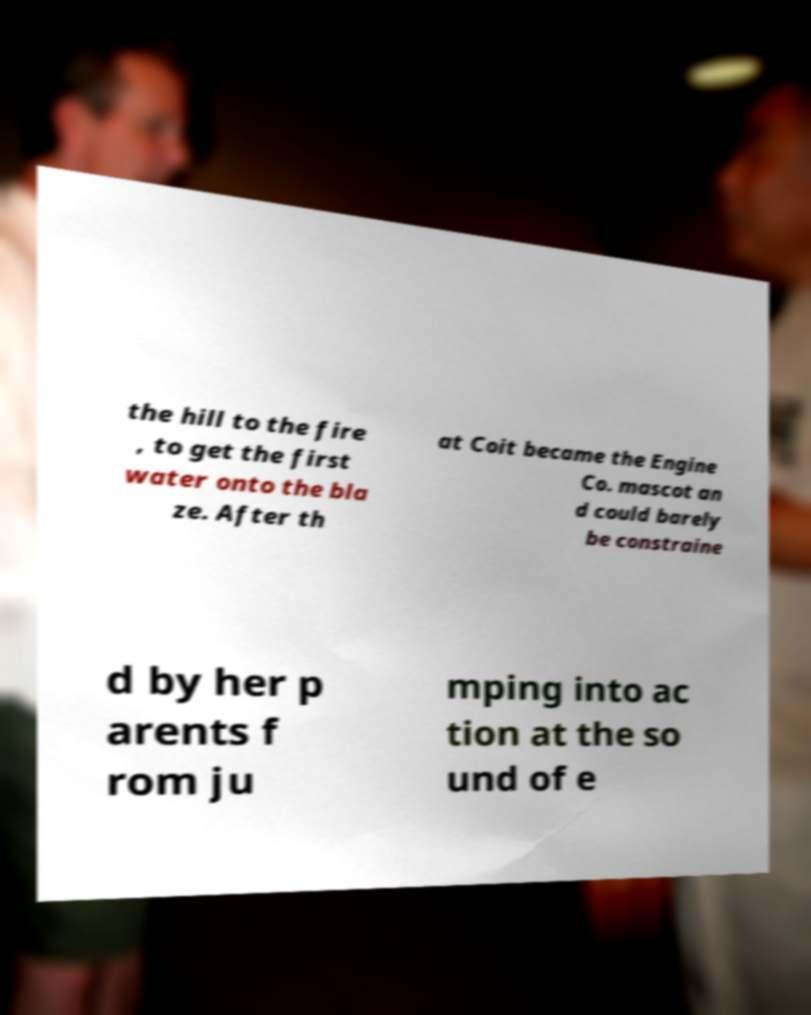Please read and relay the text visible in this image. What does it say? the hill to the fire , to get the first water onto the bla ze. After th at Coit became the Engine Co. mascot an d could barely be constraine d by her p arents f rom ju mping into ac tion at the so und of e 